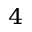<formula> <loc_0><loc_0><loc_500><loc_500>^ { 4 }</formula> 